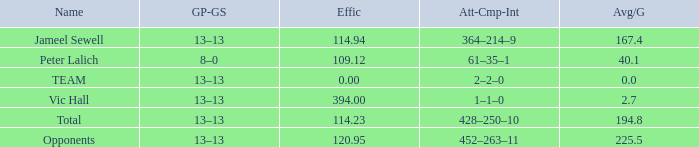Avg/G that has a Att-Cmp-Int of 1–1–0, and an Effic larger than 394 is what total? 0.0. 